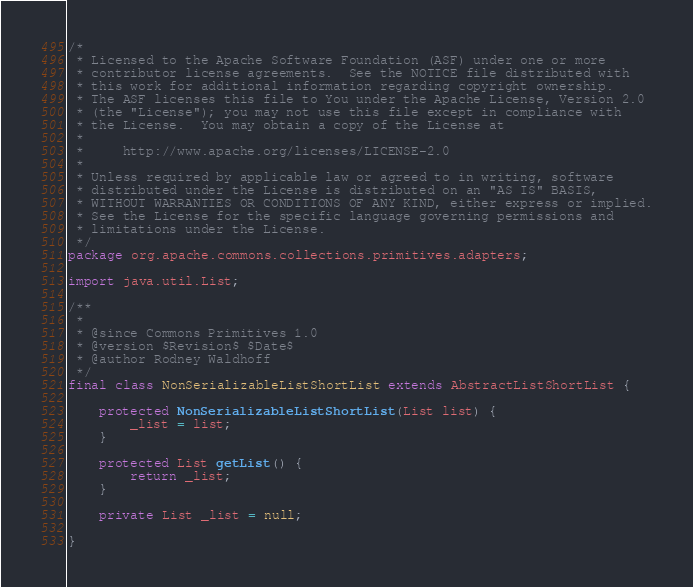<code> <loc_0><loc_0><loc_500><loc_500><_Java_>/*
 * Licensed to the Apache Software Foundation (ASF) under one or more
 * contributor license agreements.  See the NOTICE file distributed with
 * this work for additional information regarding copyright ownership.
 * The ASF licenses this file to You under the Apache License, Version 2.0
 * (the "License"); you may not use this file except in compliance with
 * the License.  You may obtain a copy of the License at
 *
 *     http://www.apache.org/licenses/LICENSE-2.0
 *
 * Unless required by applicable law or agreed to in writing, software
 * distributed under the License is distributed on an "AS IS" BASIS,
 * WITHOUT WARRANTIES OR CONDITIONS OF ANY KIND, either express or implied.
 * See the License for the specific language governing permissions and
 * limitations under the License.
 */
package org.apache.commons.collections.primitives.adapters;

import java.util.List;

/**
 *
 * @since Commons Primitives 1.0
 * @version $Revision$ $Date$
 * @author Rodney Waldhoff 
 */
final class NonSerializableListShortList extends AbstractListShortList {

    protected NonSerializableListShortList(List list) {
        _list = list;
    }
    
    protected List getList() {
        return _list;
    }
        
    private List _list = null;

}
</code> 